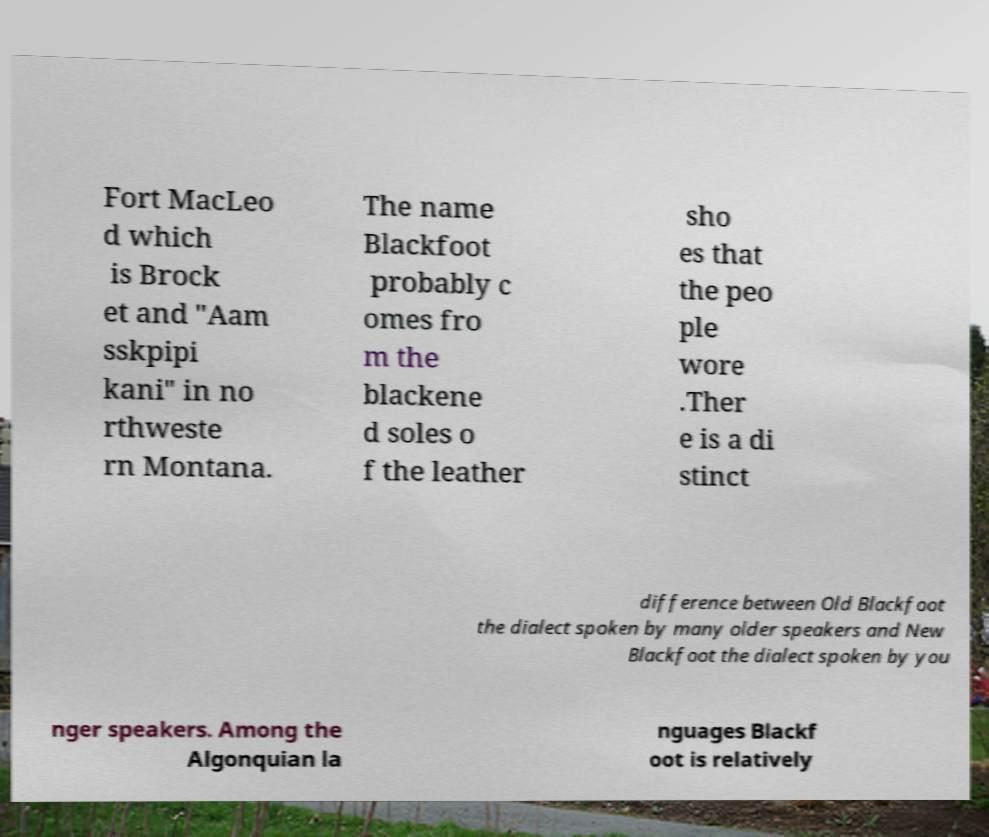Could you assist in decoding the text presented in this image and type it out clearly? Fort MacLeo d which is Brock et and "Aam sskpipi kani" in no rthweste rn Montana. The name Blackfoot probably c omes fro m the blackene d soles o f the leather sho es that the peo ple wore .Ther e is a di stinct difference between Old Blackfoot the dialect spoken by many older speakers and New Blackfoot the dialect spoken by you nger speakers. Among the Algonquian la nguages Blackf oot is relatively 